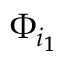Convert formula to latex. <formula><loc_0><loc_0><loc_500><loc_500>\Phi _ { i _ { 1 } }</formula> 